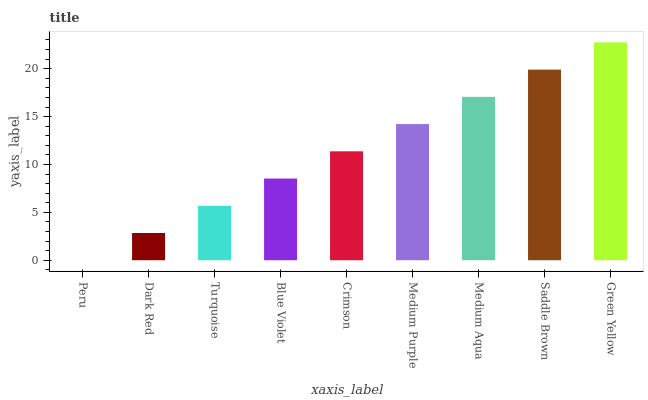Is Peru the minimum?
Answer yes or no. Yes. Is Green Yellow the maximum?
Answer yes or no. Yes. Is Dark Red the minimum?
Answer yes or no. No. Is Dark Red the maximum?
Answer yes or no. No. Is Dark Red greater than Peru?
Answer yes or no. Yes. Is Peru less than Dark Red?
Answer yes or no. Yes. Is Peru greater than Dark Red?
Answer yes or no. No. Is Dark Red less than Peru?
Answer yes or no. No. Is Crimson the high median?
Answer yes or no. Yes. Is Crimson the low median?
Answer yes or no. Yes. Is Dark Red the high median?
Answer yes or no. No. Is Blue Violet the low median?
Answer yes or no. No. 